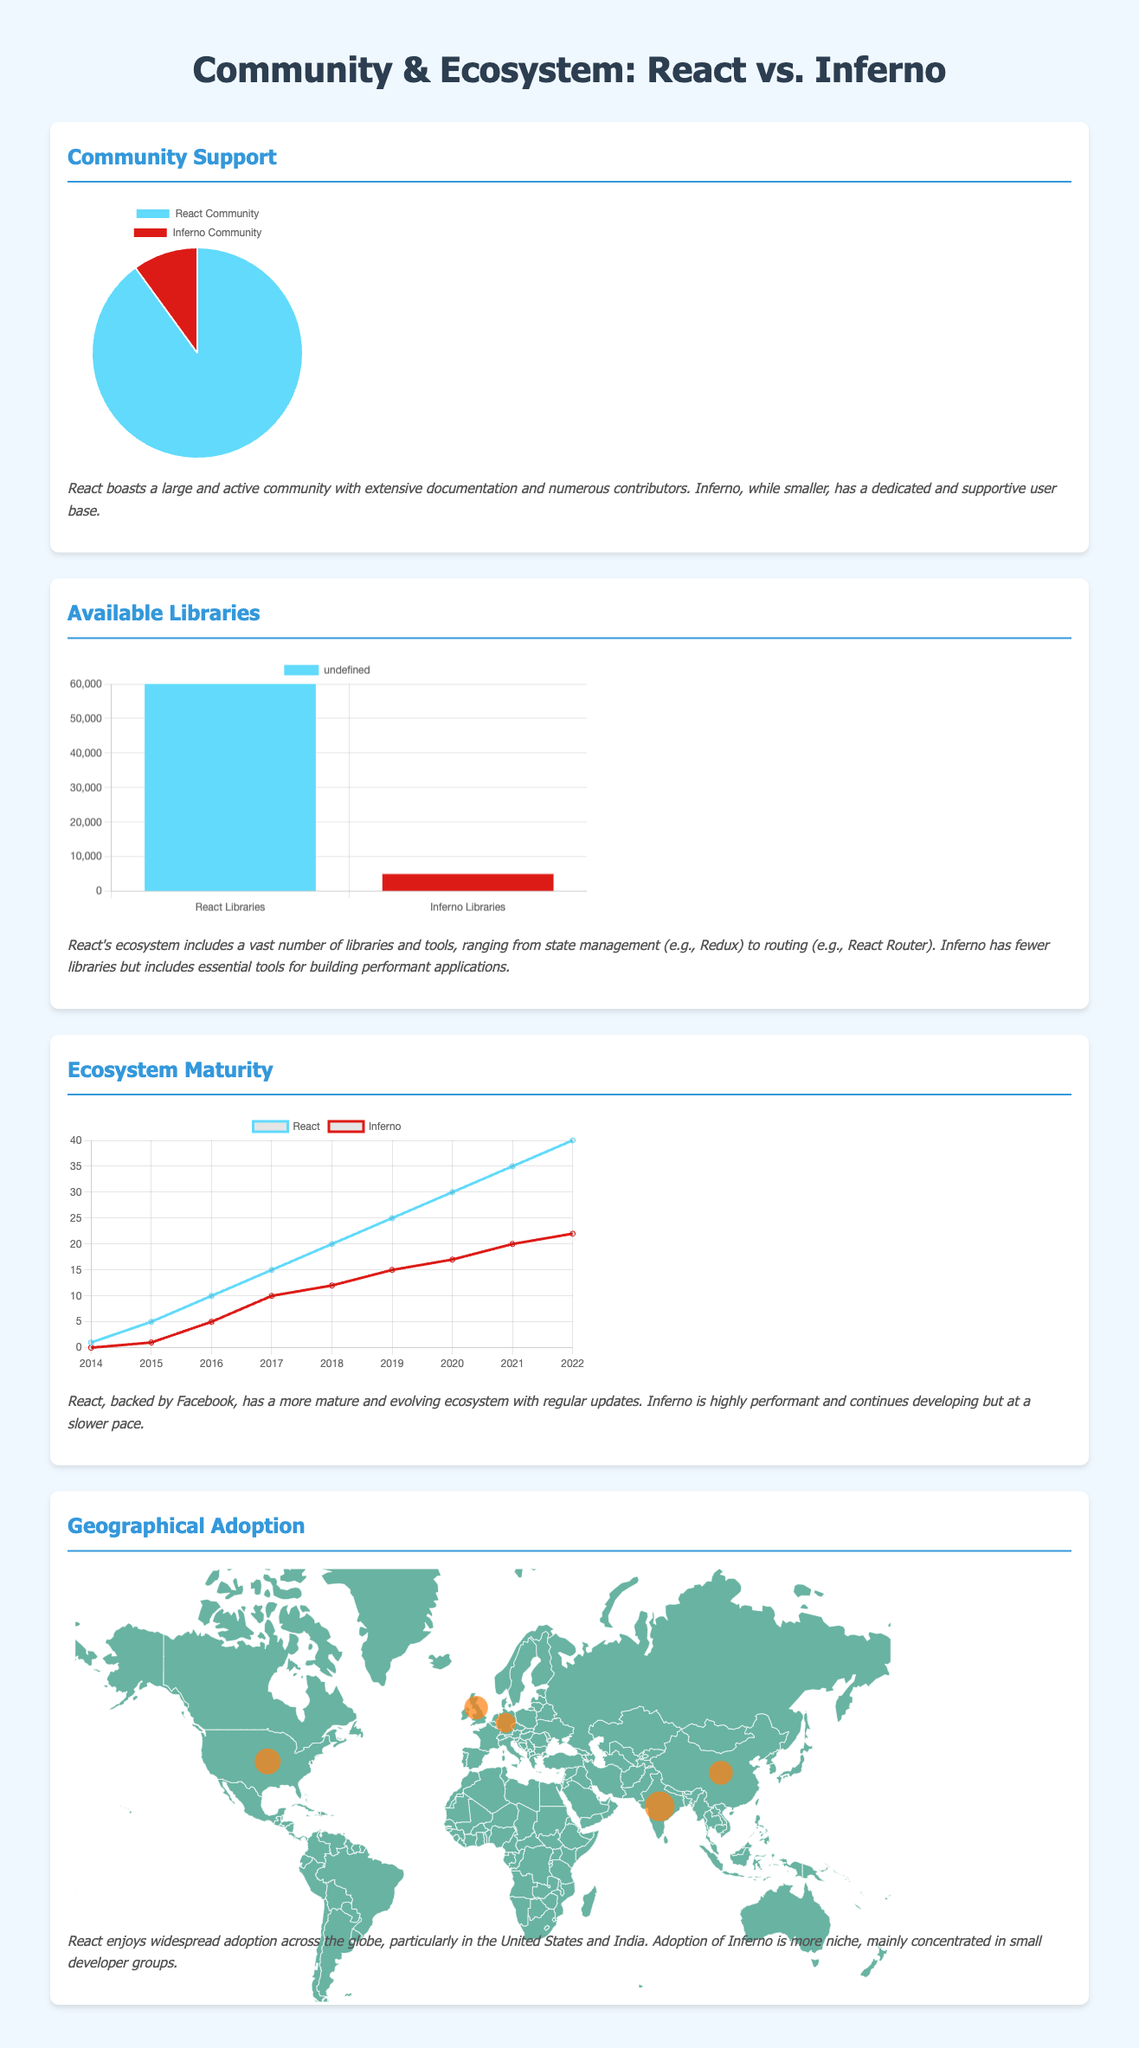What is the percentage of the React community compared to Inferno? The community pie chart shows that React has 90% while Inferno has 10%.
Answer: 90% How many third-party libraries are available for React? The bar chart indicates there are 60,000 libraries available for React.
Answer: 60000 What is the total number of libraries available for Inferno? According to the bar chart, Inferno has 5,000 libraries.
Answer: 5000 In which year did React's ecosystem maturity reach a value of 40? The line chart shows React reached a maturity value of 40 in 2022.
Answer: 2022 Which country shows the highest usage of React according to the geographical map? The description states that React usage is highest in the United States with 70%.
Answer: United States What is the React usage percentage in India? The adoption data specifies that React usage in India is 80%.
Answer: 80% What color represents React in the community support pie chart? The pie chart uses the color light blue (#61DAFB) to represent React.
Answer: Light blue How does Inferno's ecosystem maturity compare to React in 2020? In the line chart, Inferno's maturity was 17 in 2020 compared to React's 30.
Answer: 17 vs 30 Which visualization type illustrates the community support between React and Inferno? The information on community support is represented using a pie chart.
Answer: Pie chart 